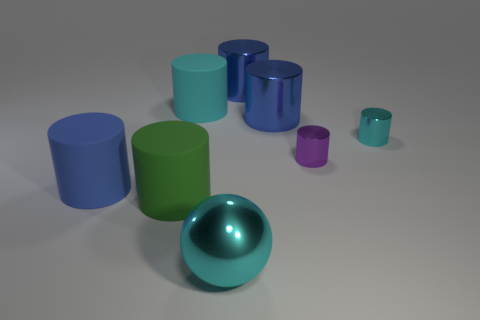What number of cubes are either cyan metal things or purple things? The question seems to contain a minor error, as there are no cubes visible in the image. However, if we're referring to cylindrical objects instead of cubes, the count would be three cyan metal cylinders and one purple cylinder, making a total of four cylinders with the described characteristics. 